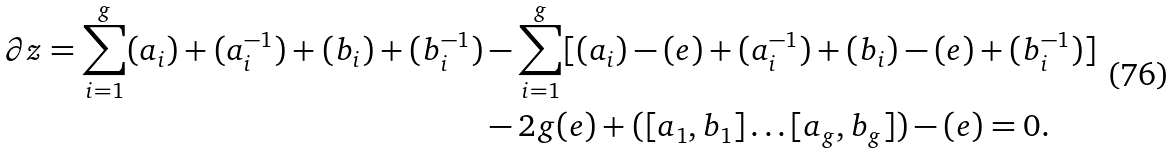Convert formula to latex. <formula><loc_0><loc_0><loc_500><loc_500>\partial z = \sum _ { i = 1 } ^ { g } ( a _ { i } ) + ( a _ { i } ^ { - 1 } ) + ( b _ { i } ) + ( b _ { i } ^ { - 1 } ) & - \sum _ { i = 1 } ^ { g } [ ( a _ { i } ) - ( e ) + ( a _ { i } ^ { - 1 } ) + ( b _ { i } ) - ( e ) + ( b _ { i } ^ { - 1 } ) ] \\ & - 2 g ( e ) + ( [ a _ { 1 } , b _ { 1 } ] \dots [ a _ { g } , b _ { g } ] ) - ( e ) = 0 .</formula> 